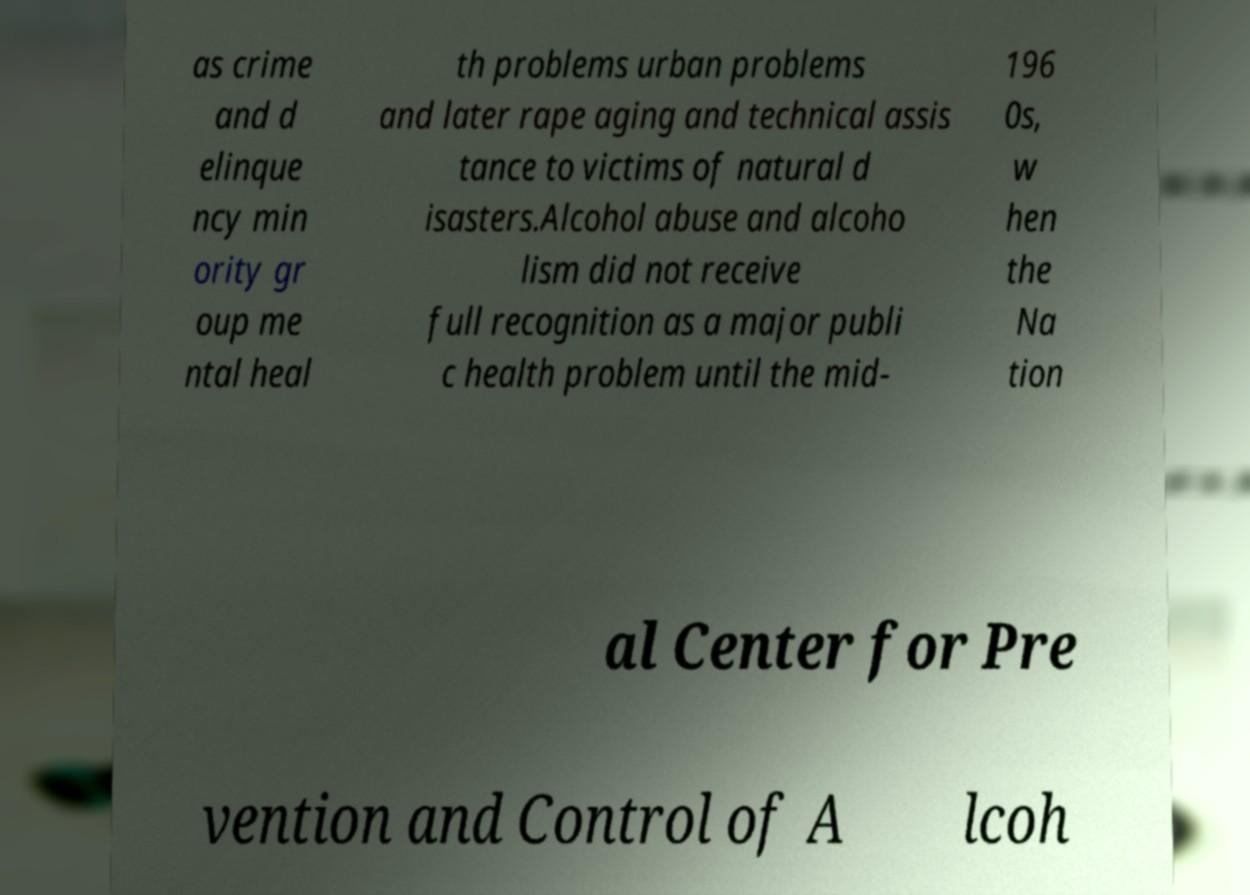Could you extract and type out the text from this image? as crime and d elinque ncy min ority gr oup me ntal heal th problems urban problems and later rape aging and technical assis tance to victims of natural d isasters.Alcohol abuse and alcoho lism did not receive full recognition as a major publi c health problem until the mid- 196 0s, w hen the Na tion al Center for Pre vention and Control of A lcoh 